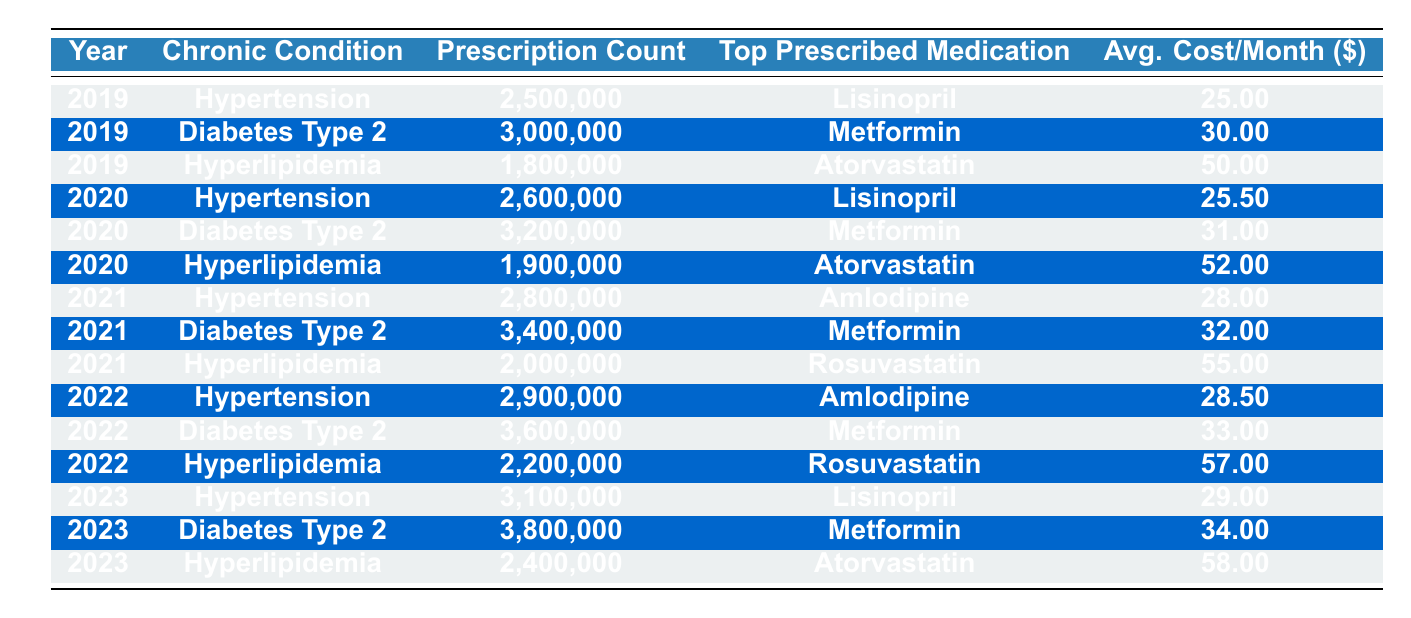What was the top prescribed medication for Diabetes Type 2 in 2022? According to the table, the top prescribed medication for Diabetes Type 2 in 2022 is Metformin.
Answer: Metformin How many prescriptions for Hyperlipidemia were there in 2021? The table shows that there were 2,000,000 prescriptions for Hyperlipidemia in 2021.
Answer: 2,000,000 What is the average cost per month for Hypertension medications over the five years? To find the average cost, we add the average costs per month for Hypertension from all years and then divide by the number of years: (25 + 25.5 + 28 + 28.5 + 29) / 5 = 27.0.
Answer: 27.0 Which chronic condition had the highest prescription count in 2023? The prescription count for Diabetes Type 2 in 2023 is 3,800,000, which is higher than the other chronic conditions.
Answer: Diabetes Type 2 Did the prescription count for Hypertension increase each year from 2019 to 2023? The prescription counts for Hypertension over the years are: 2,500,000 (2019), 2,600,000 (2020), 2,800,000 (2021), 2,900,000 (2022), 3,100,000 (2023). This shows a consistent increase each year.
Answer: Yes What was the total prescription count for Diabetes Type 2 from 2019 to 2023? The total is calculated by adding the prescription counts for each year: 3,000,000 (2019) + 3,200,000 (2020) + 3,400,000 (2021) + 3,600,000 (2022) + 3,800,000 (2023) = 16,000,000.
Answer: 16,000,000 Was Atorvastatin ever the top prescribed medication for Hypertension? According to the table, Atorvastatin was never listed as the top prescribed medication for Hypertension, which was either Lisinopril or Amlodipine.
Answer: No What was the trend in the average cost per month for Hyperlipidemia from 2019 to 2023? The average costs per month for Hyperlipidemia over the years are: 50 (2019), 52 (2020), 55 (2021), 57 (2022), 58 (2023). This shows a steady increase in cost each year.
Answer: Increasing Which year experienced the largest increase in prescription count for Hypertension compared to the previous year? The largest increase is from 2022 to 2023. The counts were 2,900,000 (2022) and 3,100,000 (2023), an increase of 200,000.
Answer: 2022 to 2023 What is the ratio of the prescription counts of Diabetes Type 2 in 2023 to Hyperlipidemia in 2023? The prescription count for Diabetes Type 2 in 2023 is 3,800,000 and for Hyperlipidemia is 2,400,000, giving a ratio of 3,800,000:2,400,000, which simplifies to 19:12.
Answer: 19:12 